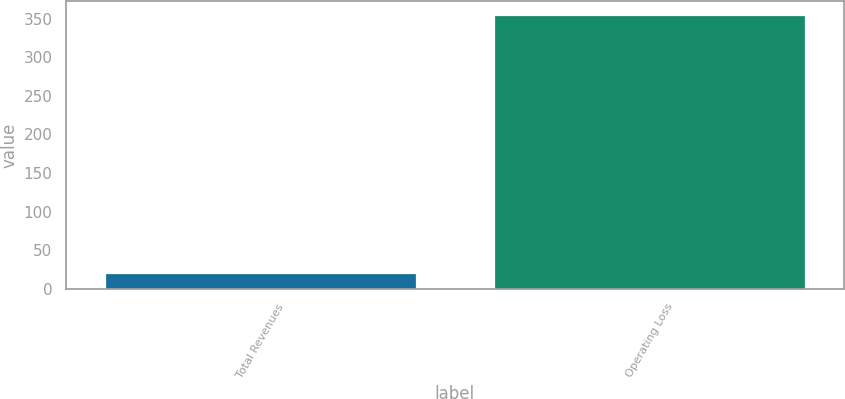Convert chart to OTSL. <chart><loc_0><loc_0><loc_500><loc_500><bar_chart><fcel>Total Revenues<fcel>Operating Loss<nl><fcel>20<fcel>355<nl></chart> 